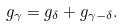Convert formula to latex. <formula><loc_0><loc_0><loc_500><loc_500>g _ { \gamma } = g _ { \delta } + g _ { \gamma - \delta } .</formula> 